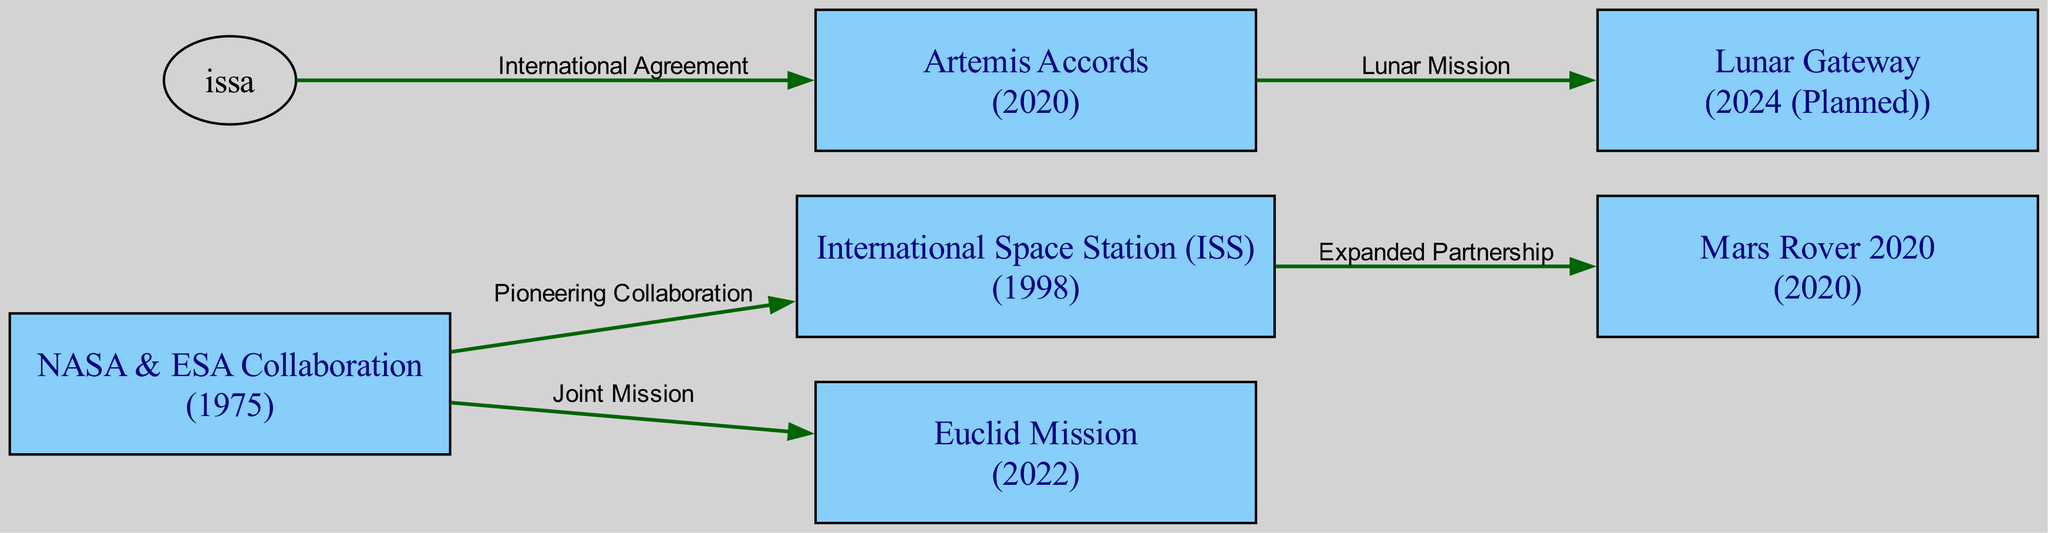What year did NASA and ESA start their collaboration? The diagram indicates that the collaboration between NASA and ESA began in the year 1975, as shown in the node labeled "NASA & ESA Collaboration".
Answer: 1975 What is the latest planned mission in the diagram? The diagram shows that the latest planned mission is the "Lunar Gateway", indicated with the year "2024 (Planned)", as represented in the corresponding node.
Answer: Lunar Gateway How many total missions are depicted in the diagram? By counting the nodes listed in the diagram, there are 6 missions illustrated: "NASA & ESA Collaboration", "International Space Station (ISS)", "Mars Rover 2020", "Artemis Accords", "Euclid Mission", and "Lunar Gateway".
Answer: 6 What relationship exists between the International Space Station and Mars Rover 2020? The edge between the "International Space Station (ISS)" node and the "Mars Rover 2020" node is labeled "Expanded Partnership", indicating a collaborative relationship that was formed as a result of their partnership.
Answer: Expanded Partnership Which two missions were connected through the Artemis Accords? The diagram connects the "Artemis Accords" node to the "Lunar Gateway" node, indicating that the relationship refers to a "Lunar Mission". This means the Artemis Accords involve the Lunar Gateway.
Answer: Lunar Gateway What type of collaboration is exemplified by the NASA and ESA relationship towards the Euclid Mission? The diagram labels the connection from "NASA & ESA Collaboration" to "Euclid Mission" as a "Joint Mission", indicating the nature of their collaborative effort on this mission.
Answer: Joint Mission How did the ISS contribute to the Mars Rover 2020 initiative? The diagram shows an edge from the "ISS" to "Mars Rover 2020" labeled "Expanded Partnership". This suggests that the partnership established through the ISS was extended to include Mars Rover 2020, enhancing collaborative efforts.
Answer: Expanded Partnership What was the significance of the year 2020 in the diagram? The year 2020 is significant because it is the year when both the "Mars Rover 2020" and the "Artemis Accords" missions were initiated, marking a notable event in the timeline of international space collaboration.
Answer: 2020 Which mission directly follows the Artemis Accords in the timeline? According to the diagram, the mission that follows the "Artemis Accords" in the timeline is the "Lunar Gateway", indicating a planned progression of missions.
Answer: Lunar Gateway 